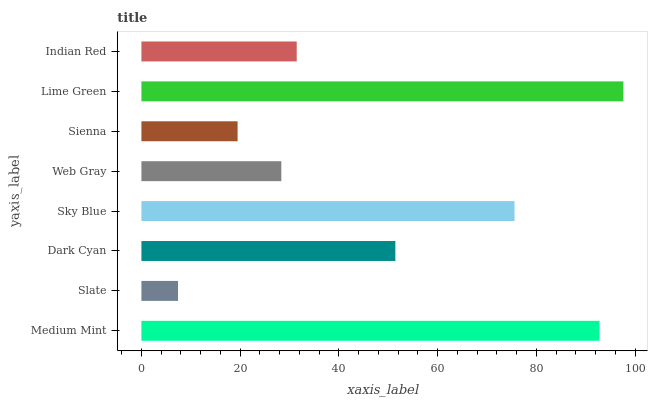Is Slate the minimum?
Answer yes or no. Yes. Is Lime Green the maximum?
Answer yes or no. Yes. Is Dark Cyan the minimum?
Answer yes or no. No. Is Dark Cyan the maximum?
Answer yes or no. No. Is Dark Cyan greater than Slate?
Answer yes or no. Yes. Is Slate less than Dark Cyan?
Answer yes or no. Yes. Is Slate greater than Dark Cyan?
Answer yes or no. No. Is Dark Cyan less than Slate?
Answer yes or no. No. Is Dark Cyan the high median?
Answer yes or no. Yes. Is Indian Red the low median?
Answer yes or no. Yes. Is Sienna the high median?
Answer yes or no. No. Is Web Gray the low median?
Answer yes or no. No. 